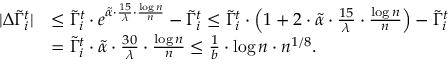<formula> <loc_0><loc_0><loc_500><loc_500>\begin{array} { r l } { | \Delta \tilde { \Gamma } _ { i } ^ { t } | } & { \leq \tilde { \Gamma } _ { i } ^ { t } \cdot e ^ { \tilde { \alpha } \cdot \frac { 1 5 } { \lambda } \cdot \frac { \log n } { n } } - \tilde { \Gamma } _ { i } ^ { t } \leq \tilde { \Gamma } _ { i } ^ { t } \cdot \left ( 1 + 2 \cdot \tilde { \alpha } \cdot \frac { 1 5 } { \lambda } \cdot \frac { \log n } { n } \right ) - \tilde { \Gamma } _ { i } ^ { t } } \\ & { = \tilde { \Gamma } _ { i } ^ { t } \cdot \tilde { \alpha } \cdot \frac { 3 0 } { \lambda } \cdot \frac { \log n } { n } \leq \frac { 1 } { b } \cdot \log n \cdot n ^ { 1 / 8 } . } \end{array}</formula> 